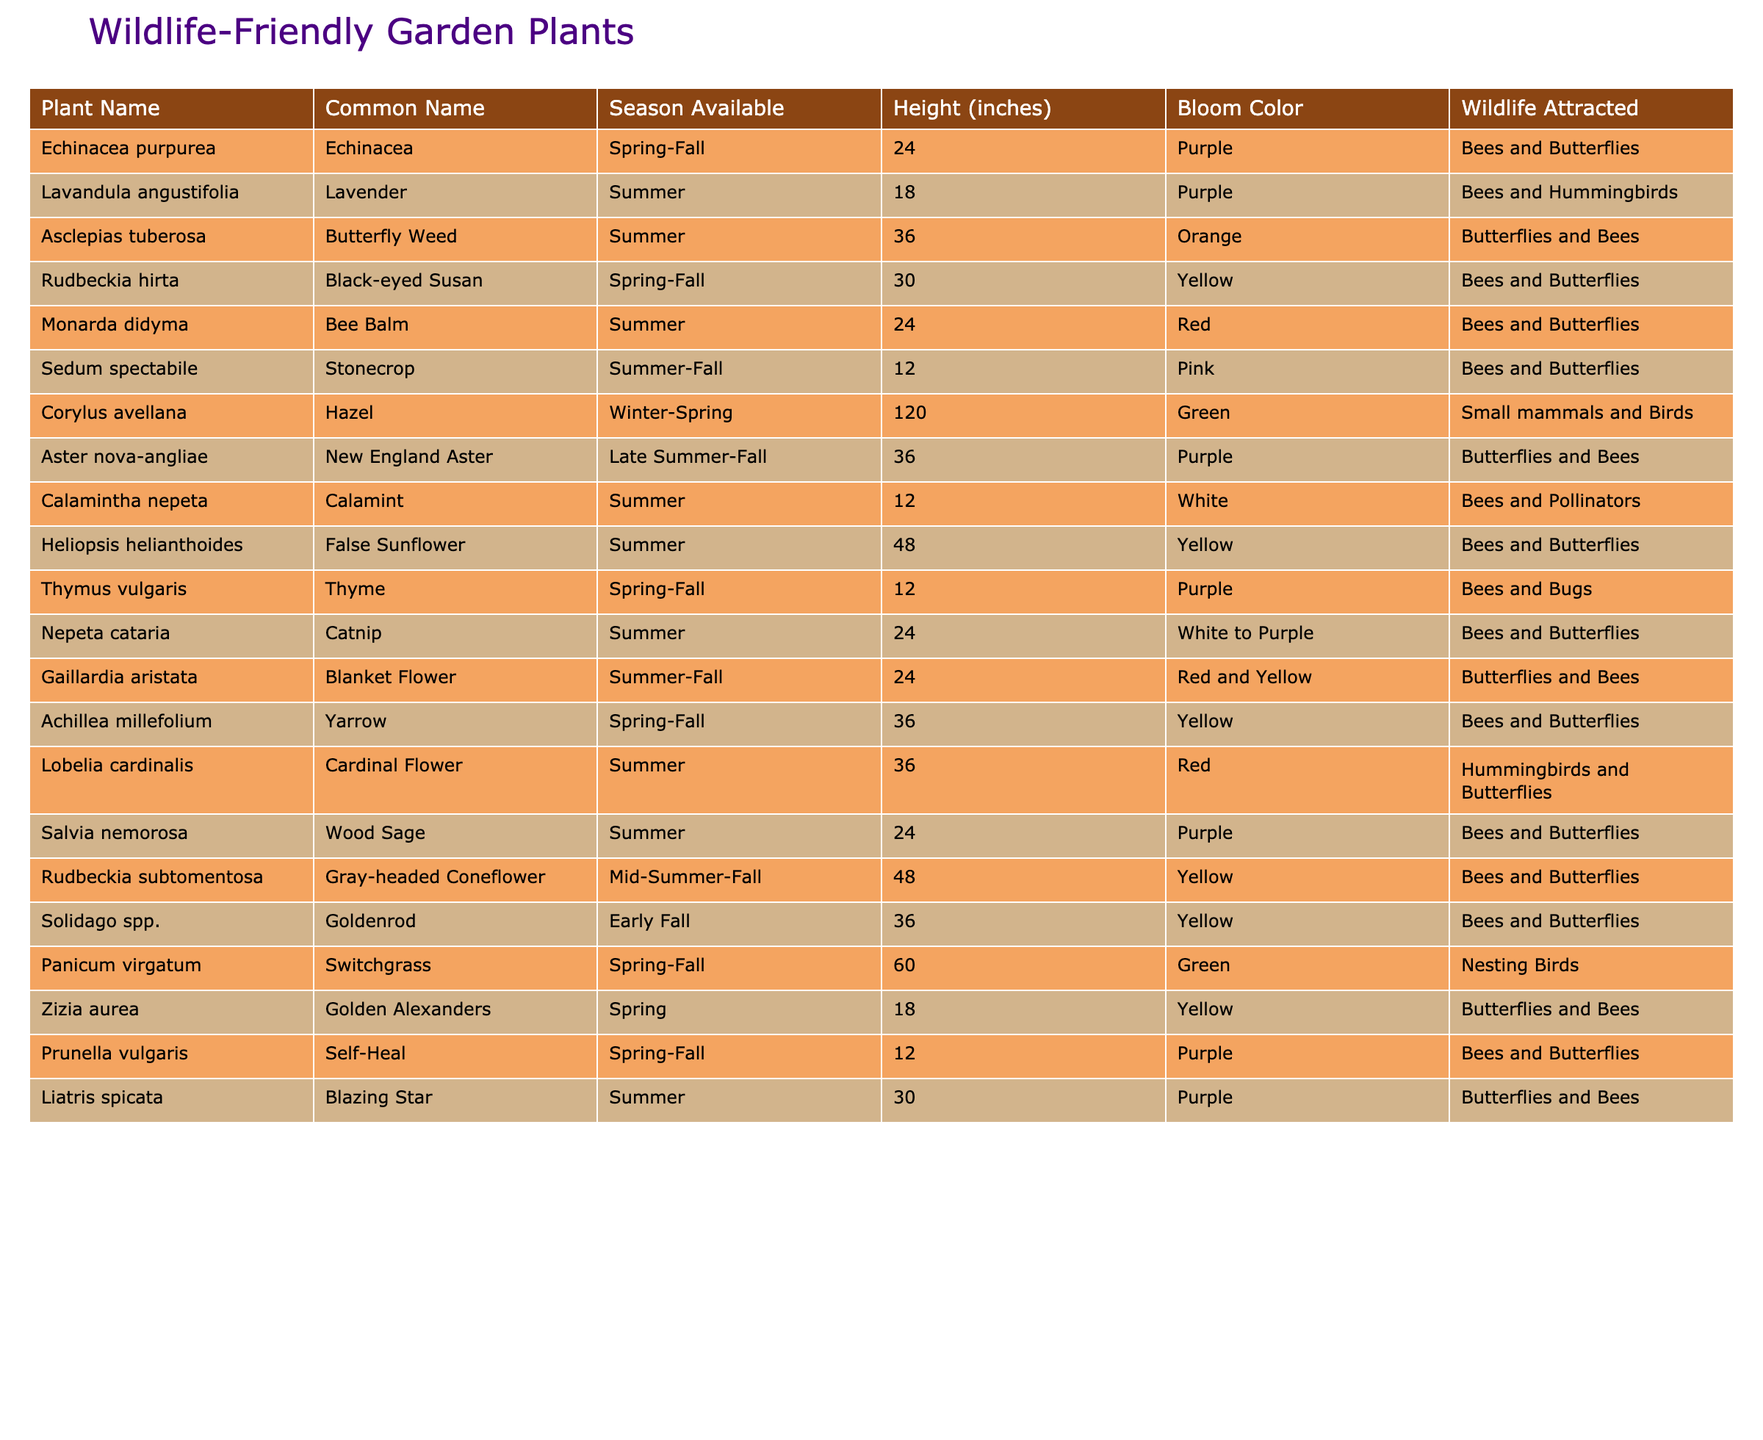What plants bloom in summer? The table lists various plants and their blooming seasons. Searching the "Season Available" column for "Summer" reveals the plants available during this season: Lavender, Butterfly Weed, Bee Balm, Stonecrop, Calamint, False Sunflower, Catnip, Liatris, and Blanket Flower.
Answer: Lavender, Butterfly Weed, Bee Balm, Stonecrop, Calamint, False Sunflower, Catnip, Liatris, Blanket Flower Which plant has the tallest height? Checking the "Height (inches)" column, the tallest plant is Corylus avellana (Hazel) with a height of 120 inches.
Answer: Corylus avellana (Hazel) Do any plants attract hummingbirds? By reviewing the "Wildlife Attracted" column, we find that Lobelia cardinalis (Cardinal Flower) and Lavandula angustifolia (Lavender) attract hummingbirds.
Answer: Yes, Lobelia cardinalis and Lavandula angustifolia What is the average height of plants that bloom in spring? Identifying the plants that bloom in spring: Echinacea, Black-eyed Susan, and Yarrow, their heights are 24, 30, and 36 inches respectively. The average height is (24 + 30 + 36) / 3 = 30 inches.
Answer: 30 inches How many species are available in spring-fall? The table shows the availability of plants in the "Season Available" column. The plants in this category are Echinacea, Black-eyed Susan, Bee Balm, Stonecrop, Thyme, Achillea, and Prunella, totaling 7 species.
Answer: 7 species What is the color of the flowers of plants that attract butterflies? Reviewing the "Bloom Color" column for plants that attract butterflies reveals colors: Purple (Echinacea, Aster), Orange (Butterfly Weed), Red (Bee Balm, Lobelia), Yellow (Rudbeckia, Goldenrod), Pink (Stonecrop), and Red and Yellow (Blanket Flower).
Answer: Purple, Orange, Red, Yellow, Pink, Red and Yellow Which plants bloom early in the season and their height? Looking at the table, Zizia aurea (Golden Alexanders) blooms in spring, which is early in the season, and has a height of 18 inches.
Answer: Zizia aurea (Golden Alexanders), 18 inches List all the wildlife attracted to Rudbeckia hirta. By checking the "Wildlife Attracted" column for Rudbeckia hirta, it shows that it attracts Bees and Butterflies.
Answer: Bees and Butterflies How many plants have pink blooms? The table lists only one plant with pink blooms, which is Sedum spectabile (Stonecrop).
Answer: 1 plant Are there any plants that are available in winter? Observing the "Season Available" column, Corylus avellana (Hazel) is the only plant that is available in winter.
Answer: Yes, Corylus avellana (Hazel) 